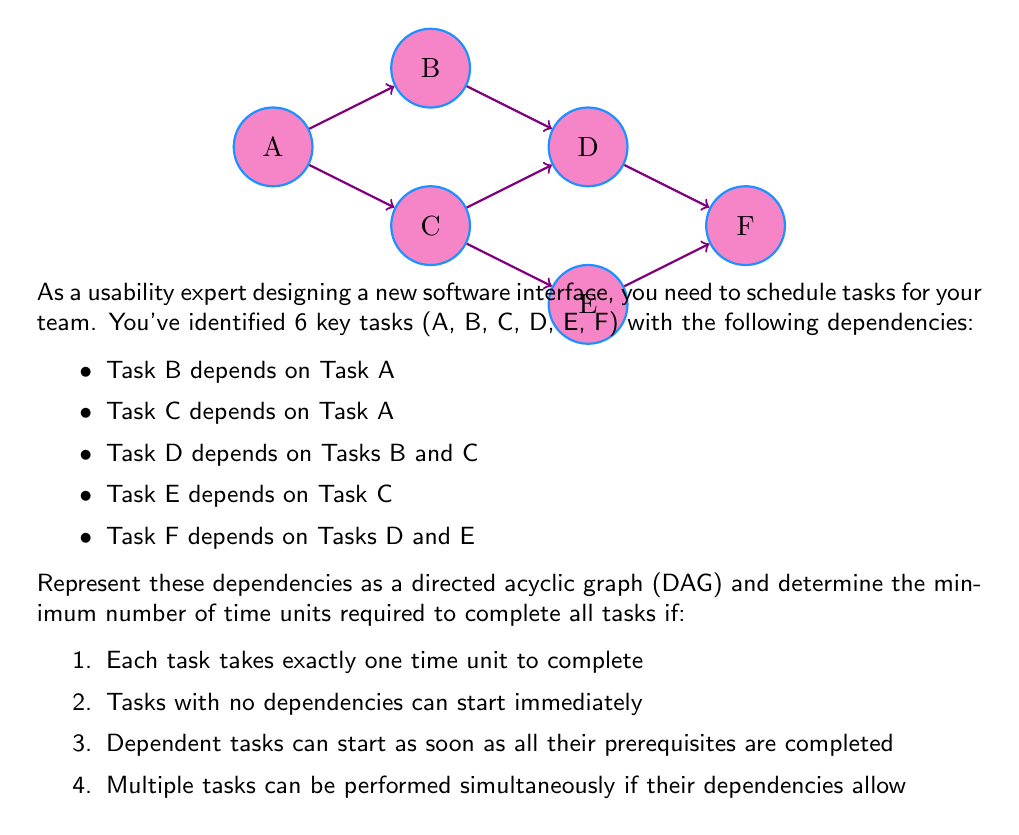Help me with this question. To solve this problem, we'll use the concept of topological sorting and critical path analysis in a DAG:

1) First, let's identify the levels in our DAG:
   Level 0: A (no dependencies)
   Level 1: B, C (depend on A)
   Level 2: D, E (D depends on B and C; E depends on C)
   Level 3: F (depends on D and E)

2) Now, let's analyze the time required for each level:
   - Level 0: Task A takes 1 time unit
   - Level 1: Tasks B and C can be done simultaneously after A, taking 1 time unit
   - Level 2: Task D must wait for both B and C, while E only waits for C. They can be done simultaneously, taking 1 time unit
   - Level 3: Task F must wait for both D and E, taking 1 time unit

3) The critical path in this DAG is A → C → D → F or A → C → E → F, both of which require 4 time units.

4) Therefore, the minimum number of time units required to complete all tasks is the length of the critical path, which is 4.

This approach ensures that all tasks are completed as quickly as possible while respecting the dependencies, which is crucial for efficient project management and user interface development in usability engineering.
Answer: 4 time units 